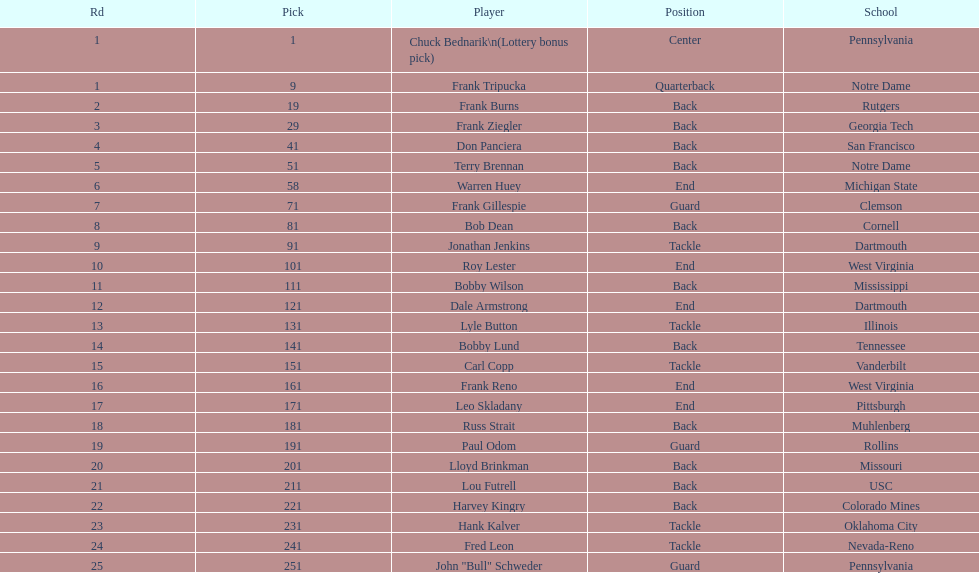How many draft picks were between frank tripucka and dale armstrong? 10. 